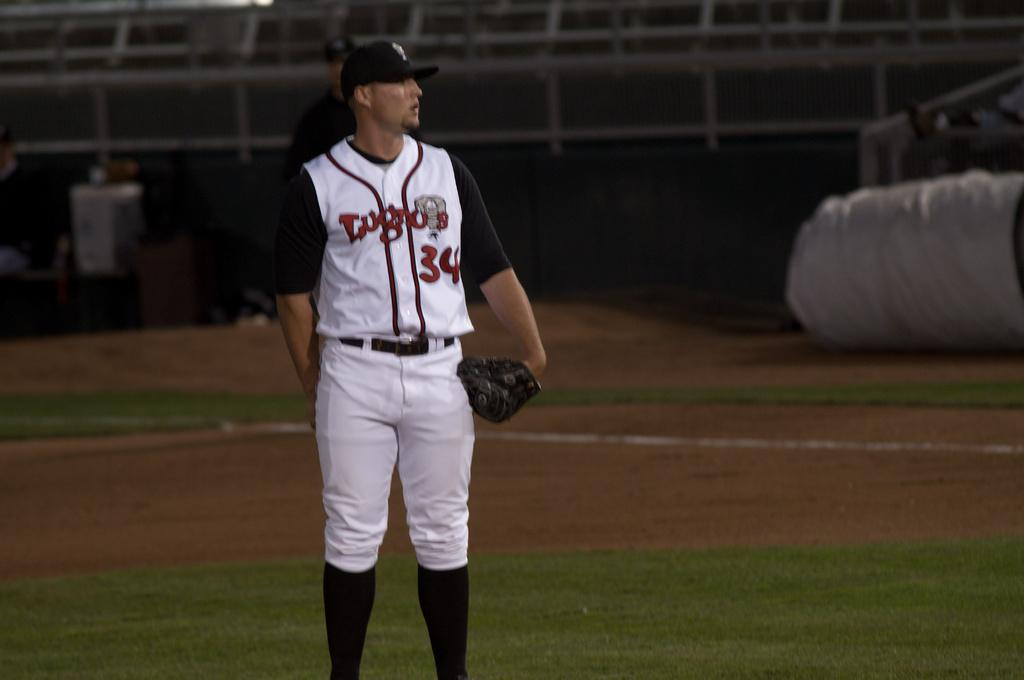Provide a one-sentence caption for the provided image. A pitcher with 34 on his jersey standing with his glove on. 